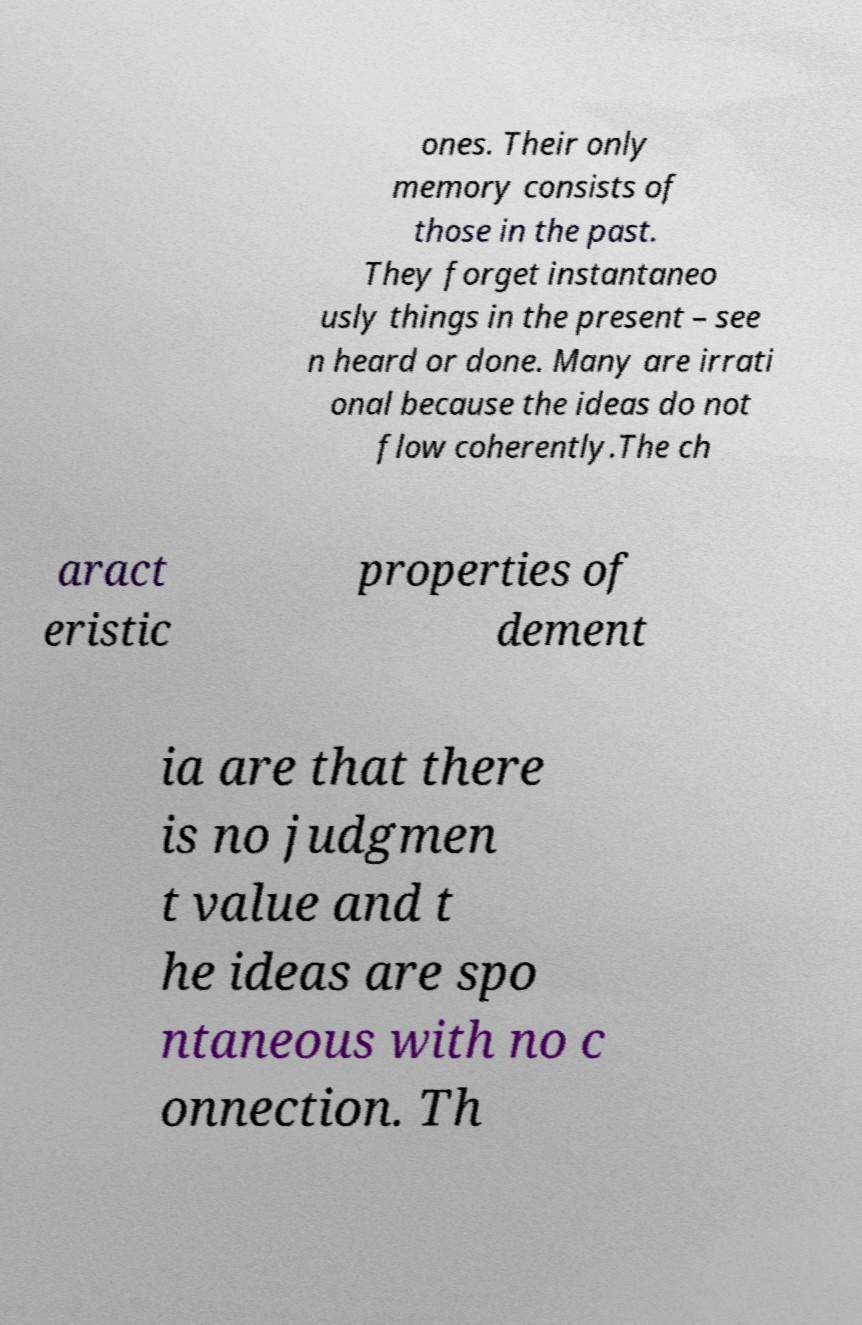There's text embedded in this image that I need extracted. Can you transcribe it verbatim? ones. Their only memory consists of those in the past. They forget instantaneo usly things in the present – see n heard or done. Many are irrati onal because the ideas do not flow coherently.The ch aract eristic properties of dement ia are that there is no judgmen t value and t he ideas are spo ntaneous with no c onnection. Th 